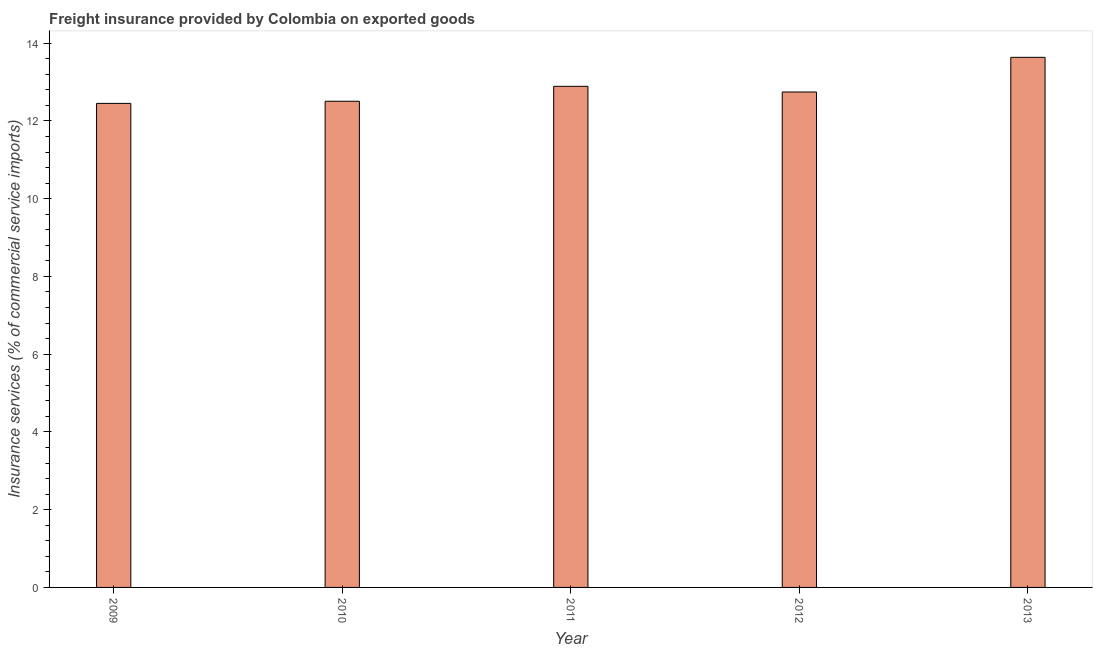What is the title of the graph?
Give a very brief answer. Freight insurance provided by Colombia on exported goods . What is the label or title of the X-axis?
Provide a short and direct response. Year. What is the label or title of the Y-axis?
Your answer should be very brief. Insurance services (% of commercial service imports). What is the freight insurance in 2011?
Give a very brief answer. 12.89. Across all years, what is the maximum freight insurance?
Your answer should be very brief. 13.64. Across all years, what is the minimum freight insurance?
Offer a very short reply. 12.45. What is the sum of the freight insurance?
Offer a very short reply. 64.22. What is the difference between the freight insurance in 2012 and 2013?
Provide a succinct answer. -0.89. What is the average freight insurance per year?
Offer a very short reply. 12.85. What is the median freight insurance?
Your answer should be very brief. 12.74. In how many years, is the freight insurance greater than 9.6 %?
Make the answer very short. 5. What is the ratio of the freight insurance in 2012 to that in 2013?
Provide a succinct answer. 0.94. Is the difference between the freight insurance in 2009 and 2012 greater than the difference between any two years?
Give a very brief answer. No. What is the difference between the highest and the second highest freight insurance?
Offer a very short reply. 0.75. Is the sum of the freight insurance in 2011 and 2013 greater than the maximum freight insurance across all years?
Give a very brief answer. Yes. What is the difference between the highest and the lowest freight insurance?
Your answer should be compact. 1.18. Are all the bars in the graph horizontal?
Keep it short and to the point. No. How many years are there in the graph?
Make the answer very short. 5. Are the values on the major ticks of Y-axis written in scientific E-notation?
Provide a short and direct response. No. What is the Insurance services (% of commercial service imports) in 2009?
Provide a short and direct response. 12.45. What is the Insurance services (% of commercial service imports) in 2010?
Offer a very short reply. 12.51. What is the Insurance services (% of commercial service imports) in 2011?
Offer a terse response. 12.89. What is the Insurance services (% of commercial service imports) in 2012?
Make the answer very short. 12.74. What is the Insurance services (% of commercial service imports) of 2013?
Ensure brevity in your answer.  13.64. What is the difference between the Insurance services (% of commercial service imports) in 2009 and 2010?
Offer a terse response. -0.06. What is the difference between the Insurance services (% of commercial service imports) in 2009 and 2011?
Keep it short and to the point. -0.44. What is the difference between the Insurance services (% of commercial service imports) in 2009 and 2012?
Offer a terse response. -0.29. What is the difference between the Insurance services (% of commercial service imports) in 2009 and 2013?
Keep it short and to the point. -1.18. What is the difference between the Insurance services (% of commercial service imports) in 2010 and 2011?
Your answer should be very brief. -0.38. What is the difference between the Insurance services (% of commercial service imports) in 2010 and 2012?
Ensure brevity in your answer.  -0.24. What is the difference between the Insurance services (% of commercial service imports) in 2010 and 2013?
Your answer should be very brief. -1.13. What is the difference between the Insurance services (% of commercial service imports) in 2011 and 2012?
Provide a succinct answer. 0.15. What is the difference between the Insurance services (% of commercial service imports) in 2011 and 2013?
Keep it short and to the point. -0.75. What is the difference between the Insurance services (% of commercial service imports) in 2012 and 2013?
Your answer should be compact. -0.89. What is the ratio of the Insurance services (% of commercial service imports) in 2009 to that in 2011?
Make the answer very short. 0.97. What is the ratio of the Insurance services (% of commercial service imports) in 2009 to that in 2012?
Your answer should be very brief. 0.98. What is the ratio of the Insurance services (% of commercial service imports) in 2010 to that in 2012?
Offer a very short reply. 0.98. What is the ratio of the Insurance services (% of commercial service imports) in 2010 to that in 2013?
Give a very brief answer. 0.92. What is the ratio of the Insurance services (% of commercial service imports) in 2011 to that in 2012?
Your answer should be compact. 1.01. What is the ratio of the Insurance services (% of commercial service imports) in 2011 to that in 2013?
Provide a succinct answer. 0.94. What is the ratio of the Insurance services (% of commercial service imports) in 2012 to that in 2013?
Provide a succinct answer. 0.94. 